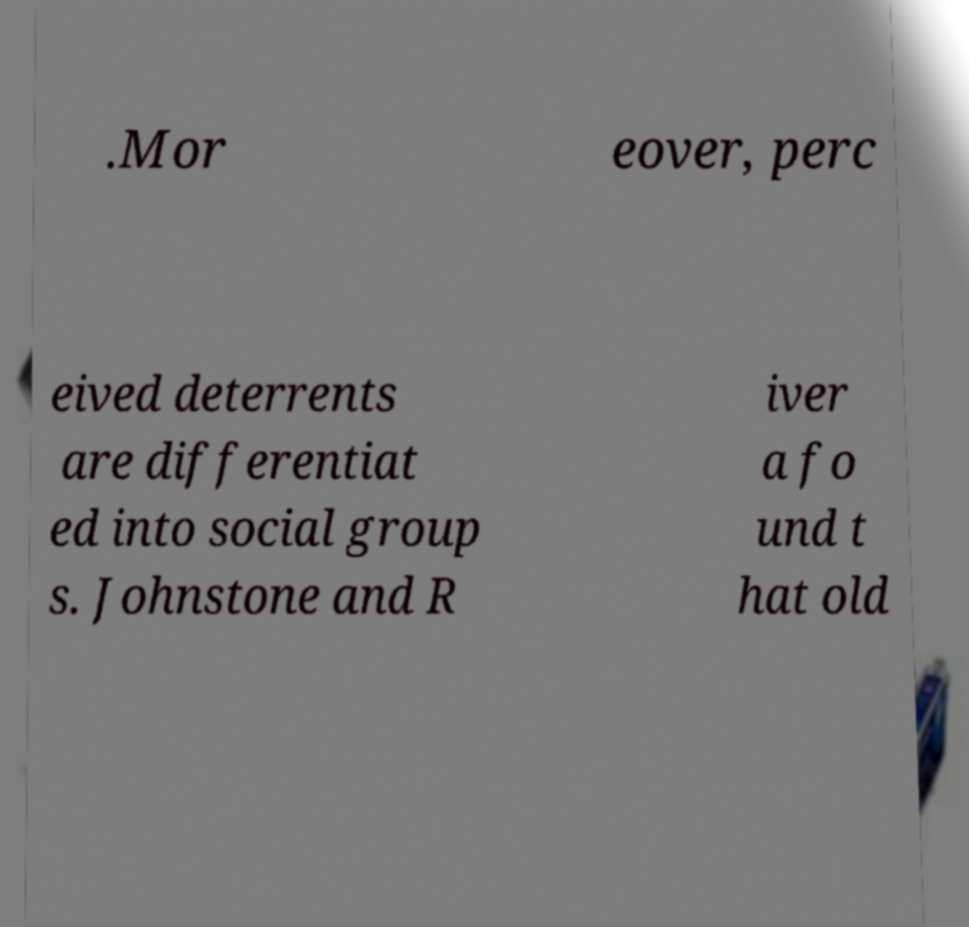Please read and relay the text visible in this image. What does it say? .Mor eover, perc eived deterrents are differentiat ed into social group s. Johnstone and R iver a fo und t hat old 